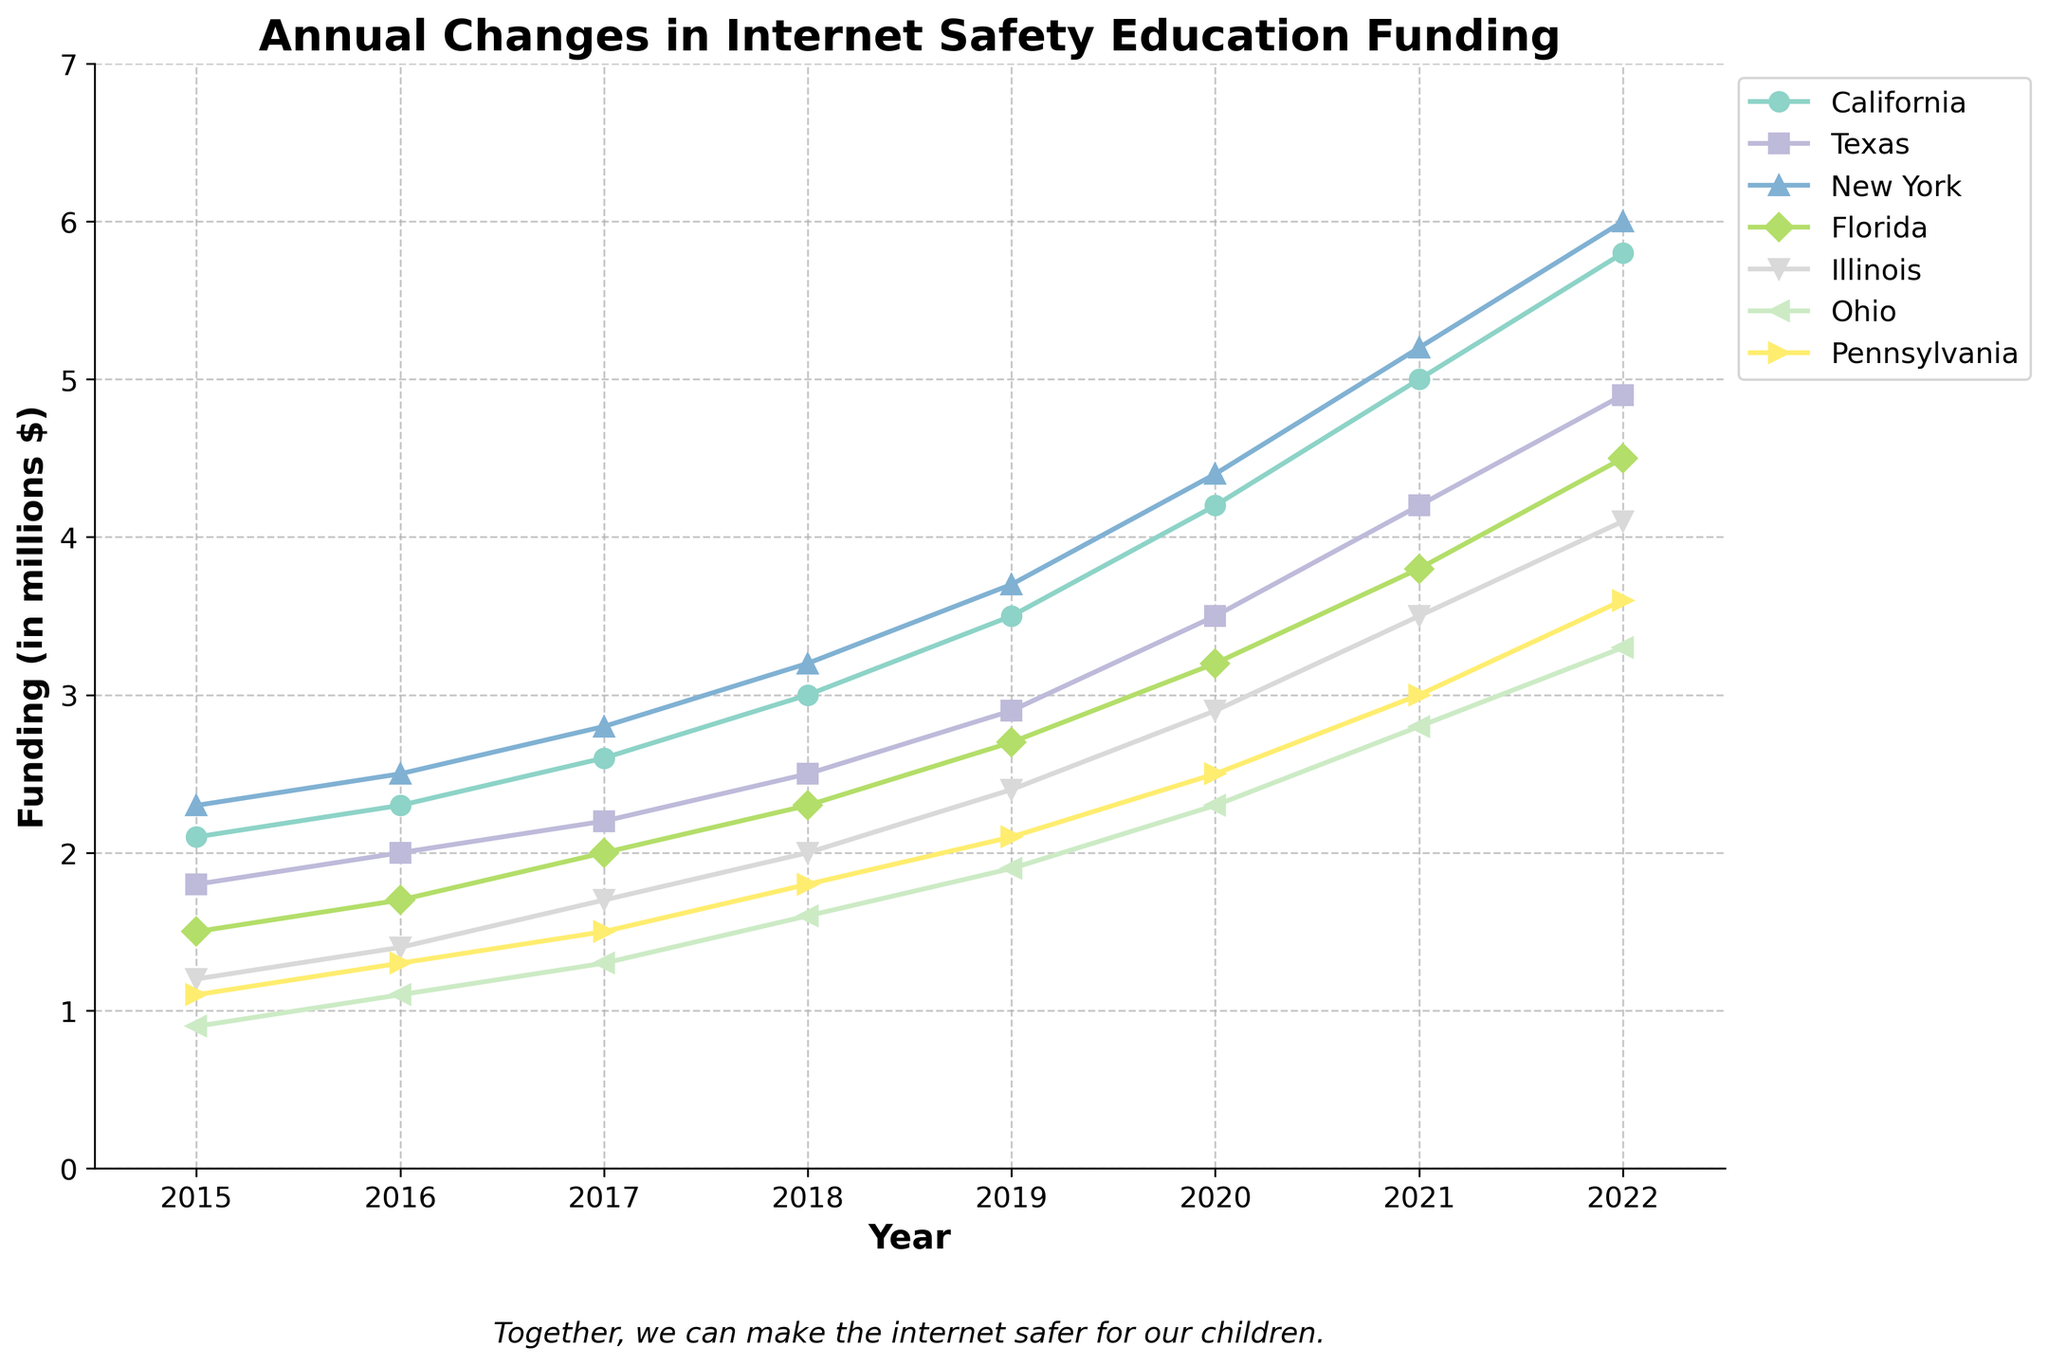Which state had the highest funding in 2022? To find the state with the highest funding in 2022, look at the values for each state in the 2022 column and identify the highest number.
Answer: New York How did Florida’s funding change from 2020 to 2021? Compare Florida's funding values in the years 2020 and 2021 by looking at the points for those years on Florida’s line. Calculate the difference (3.8 - 3.2 = 0.6).
Answer: Increased by 0.6 million Which state had the smallest increase in funding between 2016 and 2017? Calculate the funding increase for each state by subtracting the 2016 funding from the 2017 funding and find the smallest increase. For Ohio: 1.3 - 1.1 = 0.2. Compare it with others (California: 2.6-2.3=0.3, Texas: 2.2-2.0=0.2, New York: 2.8-2.5=0.3, Florida: 2.0-1.7=0.3, Illinois: 1.7-1.4=0.3, Pennsylvania: 1.5-1.3=0.2).
Answer: Ohio, Texas, and Pennsylvania Which state showed the most consistent year-over-year funding growth? Assess the smoothness of each state’s line by checking for consistent positive slopes between consecutive years. Consider California’s steady slope from 2.1 in 2015 to 5.8 in 2022.
Answer: California How much more funding did California receive compared to Ohio in 2021? Determine the funding for California and Ohio in 2021 and calculate the difference (5.0 - 2.8 = 2.2).
Answer: 2.2 million In which year did New York see the largest single-year increase in funding? Check the year-over-year changes for New York by noting the largest gap between points. From 2016 to 2017: 0.3, 2017 to 2018: 0.4, 2018 to 2019: 0.5, 2019 to 2020: 0.7, 2020 to 2021: 0.8, 2021 to 2022: 0.8. The largest gap is from 2020 to 2021 or 2021 to 2022 (0.8 each).
Answer: 2020 to 2021 or 2021 to 2022 What is the average funding for Illinois between 2018 and 2020? Sum up Illinois’s funding values for 2018, 2019, and 2020, then divide by 3. (2.0 + 2.4 + 2.9 = 7.3, 7.3 / 3 = 2.43).
Answer: 2.43 million Which state had the highest percentage increase in funding from 2015 to 2022? Calculate the percentage increase for each state over the period [(final value - initial value) / initial value * 100]. For example, for New York: [(6.0 - 2.3) / 2.3 * 100 = 160.87%]. Compare it to others.
Answer: New York (160.87%) Which state saw its funding double the fastest? Identify the year when each state's funding doubled from its starting value in 2015. For example, Pennsylvania doubled from 1.1 in 2015 to 2.2 by 2019.
Answer: Pennsylvania (By 2019) 